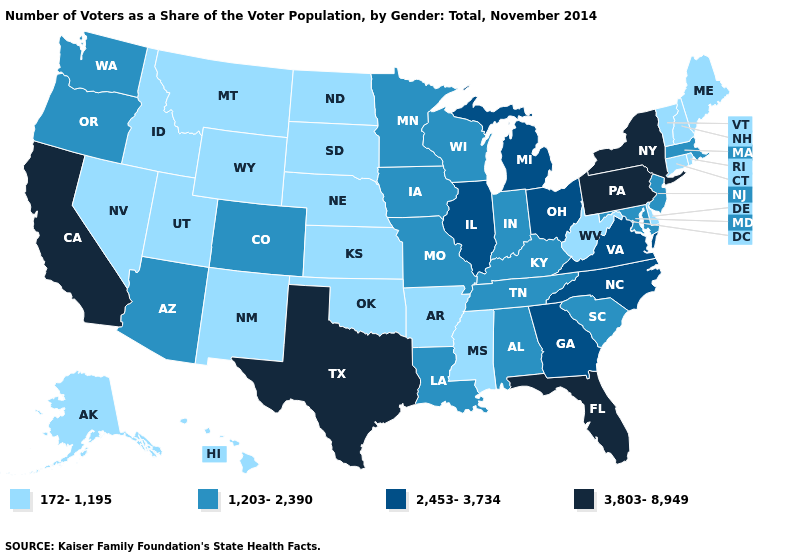What is the value of Alaska?
Short answer required. 172-1,195. What is the highest value in states that border Vermont?
Keep it brief. 3,803-8,949. What is the lowest value in the USA?
Write a very short answer. 172-1,195. Which states have the highest value in the USA?
Be succinct. California, Florida, New York, Pennsylvania, Texas. Among the states that border Kentucky , does West Virginia have the lowest value?
Write a very short answer. Yes. Does Nebraska have the lowest value in the MidWest?
Be succinct. Yes. Does Illinois have the same value as Michigan?
Concise answer only. Yes. Name the states that have a value in the range 3,803-8,949?
Answer briefly. California, Florida, New York, Pennsylvania, Texas. What is the value of Florida?
Answer briefly. 3,803-8,949. Name the states that have a value in the range 172-1,195?
Short answer required. Alaska, Arkansas, Connecticut, Delaware, Hawaii, Idaho, Kansas, Maine, Mississippi, Montana, Nebraska, Nevada, New Hampshire, New Mexico, North Dakota, Oklahoma, Rhode Island, South Dakota, Utah, Vermont, West Virginia, Wyoming. Name the states that have a value in the range 1,203-2,390?
Keep it brief. Alabama, Arizona, Colorado, Indiana, Iowa, Kentucky, Louisiana, Maryland, Massachusetts, Minnesota, Missouri, New Jersey, Oregon, South Carolina, Tennessee, Washington, Wisconsin. What is the value of Delaware?
Be succinct. 172-1,195. Does Wisconsin have the lowest value in the MidWest?
Short answer required. No. What is the lowest value in states that border Michigan?
Concise answer only. 1,203-2,390. How many symbols are there in the legend?
Write a very short answer. 4. 